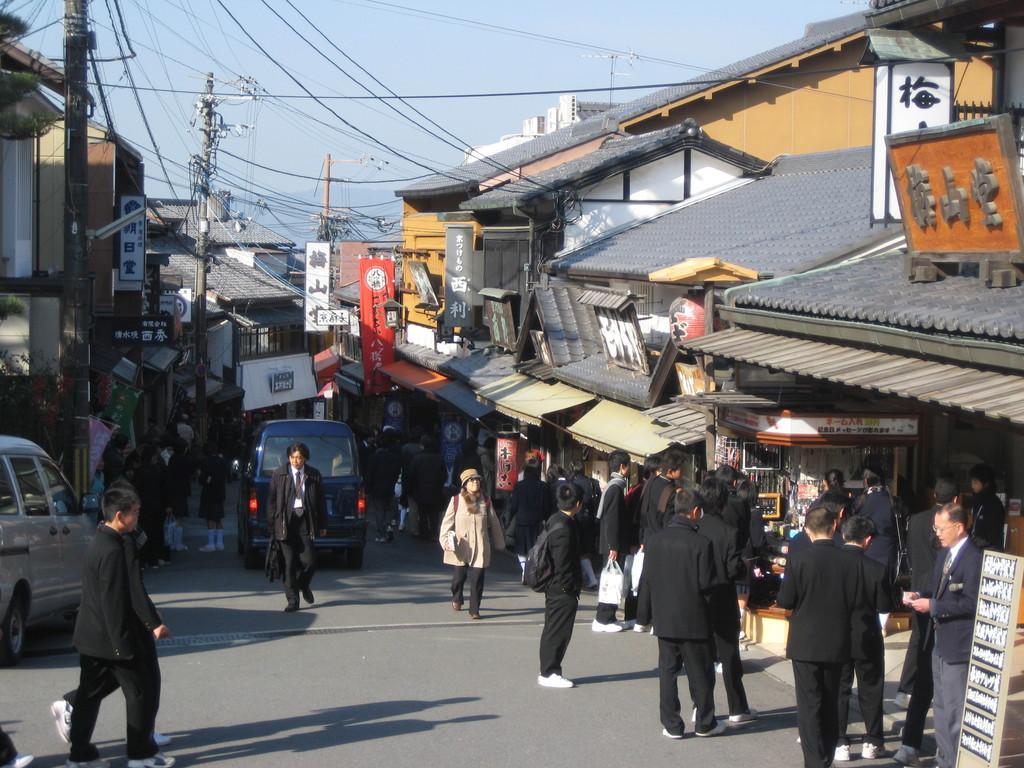In one or two sentences, can you explain what this image depicts? This image consists of many people standing and walking on the road. At the bottom, there is a road. In this image, there are two vehicles. On the left and right, there are small houses and buildings along with the board. At the top, there are many wires connected to the poles. And there is a sky. 